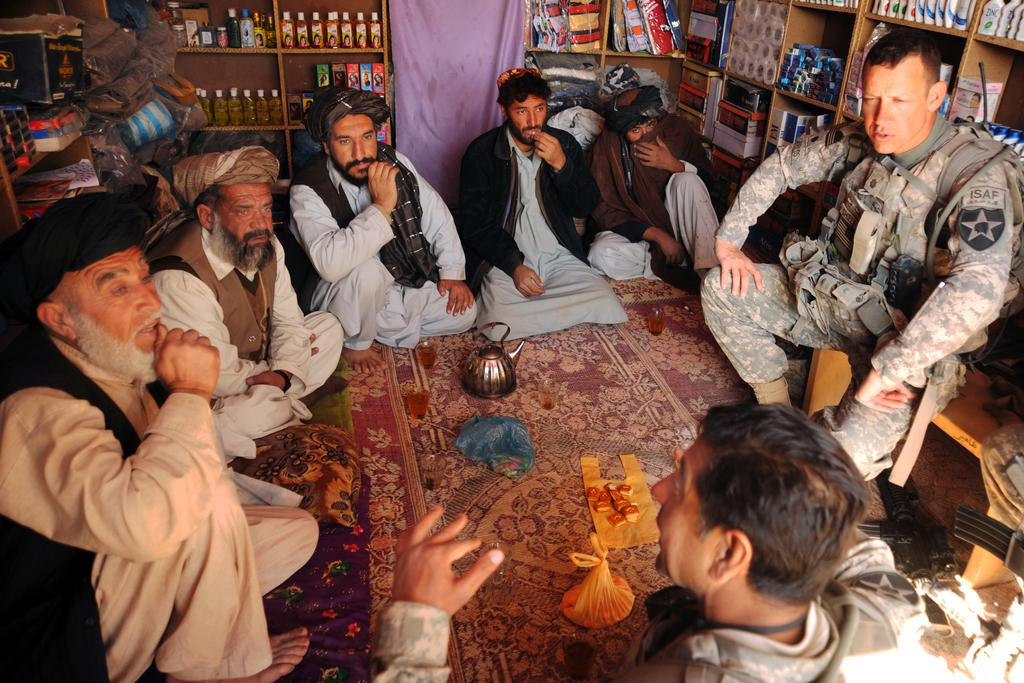What are the people in the image doing? The group of people is sitting on the floor in the image. Can you describe the attire of one of the individuals in the group? One person in the group is wearing a military uniform. What can be seen in the background of the image? There are racks with items in the background of the image. What type of insect can be seen crawling on the seashore in the image? There is no seashore or insect present in the image. 